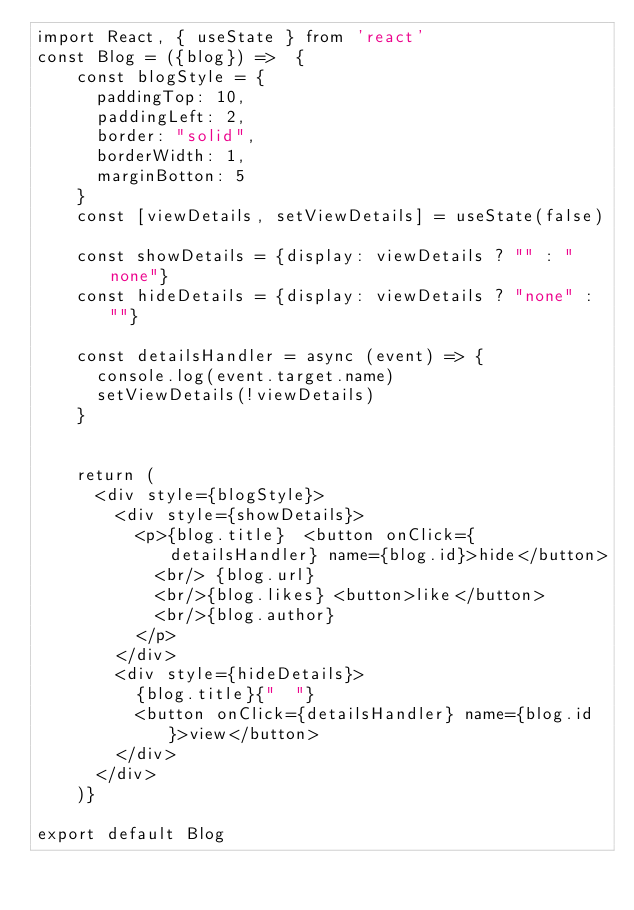<code> <loc_0><loc_0><loc_500><loc_500><_JavaScript_>import React, { useState } from 'react'
const Blog = ({blog}) =>  {
    const blogStyle = {
      paddingTop: 10,
      paddingLeft: 2,
      border: "solid",
      borderWidth: 1,
      marginBotton: 5
    }
    const [viewDetails, setViewDetails] = useState(false)

    const showDetails = {display: viewDetails ? "" : "none"}
    const hideDetails = {display: viewDetails ? "none" : ""}

    const detailsHandler = async (event) => {
      console.log(event.target.name)  
      setViewDetails(!viewDetails)
    }


    return (
      <div style={blogStyle}>
        <div style={showDetails}>
          <p>{blog.title}  <button onClick={detailsHandler} name={blog.id}>hide</button>
            <br/> {blog.url} 
            <br/>{blog.likes} <button>like</button>
            <br/>{blog.author}  
          </p>  
        </div> 
        <div style={hideDetails}>
          {blog.title}{"  "}
          <button onClick={detailsHandler} name={blog.id}>view</button>
        </div>  
      </div>
    )}

export default Blog</code> 